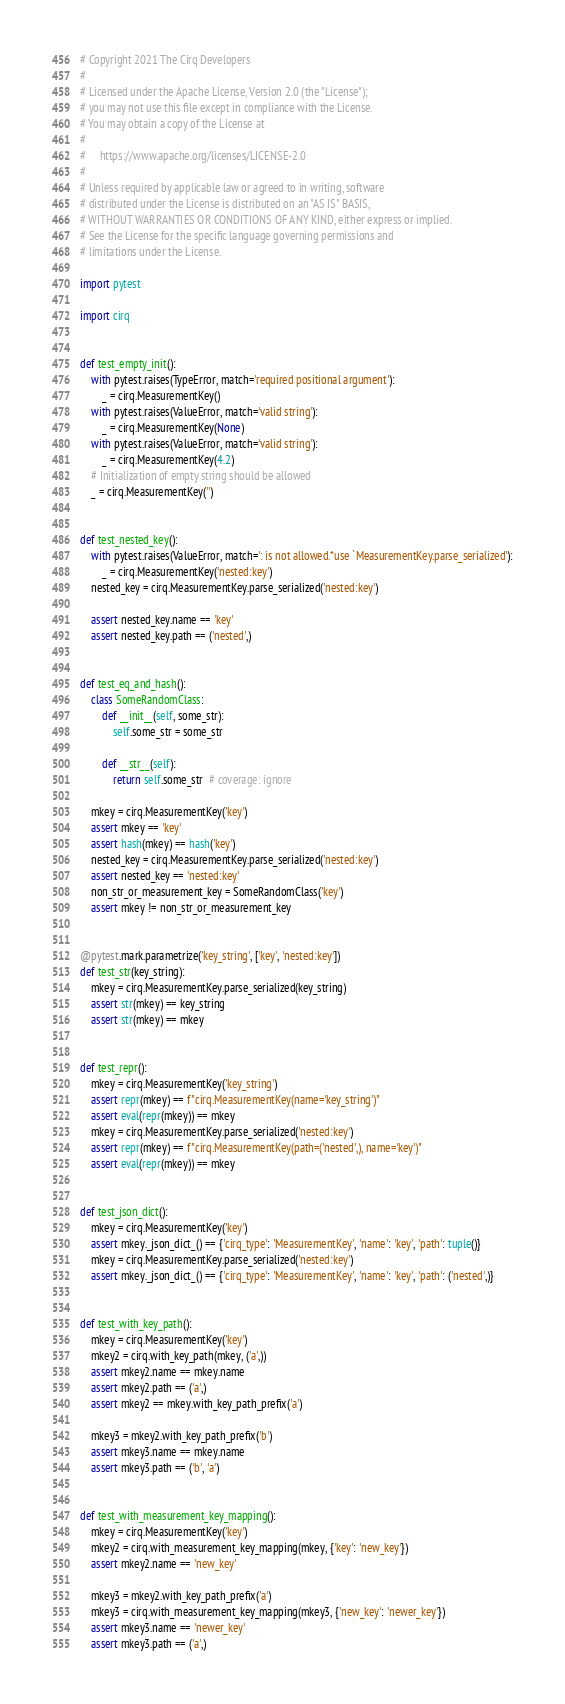<code> <loc_0><loc_0><loc_500><loc_500><_Python_># Copyright 2021 The Cirq Developers
#
# Licensed under the Apache License, Version 2.0 (the "License");
# you may not use this file except in compliance with the License.
# You may obtain a copy of the License at
#
#     https://www.apache.org/licenses/LICENSE-2.0
#
# Unless required by applicable law or agreed to in writing, software
# distributed under the License is distributed on an "AS IS" BASIS,
# WITHOUT WARRANTIES OR CONDITIONS OF ANY KIND, either express or implied.
# See the License for the specific language governing permissions and
# limitations under the License.

import pytest

import cirq


def test_empty_init():
    with pytest.raises(TypeError, match='required positional argument'):
        _ = cirq.MeasurementKey()
    with pytest.raises(ValueError, match='valid string'):
        _ = cirq.MeasurementKey(None)
    with pytest.raises(ValueError, match='valid string'):
        _ = cirq.MeasurementKey(4.2)
    # Initialization of empty string should be allowed
    _ = cirq.MeasurementKey('')


def test_nested_key():
    with pytest.raises(ValueError, match=': is not allowed.*use `MeasurementKey.parse_serialized'):
        _ = cirq.MeasurementKey('nested:key')
    nested_key = cirq.MeasurementKey.parse_serialized('nested:key')

    assert nested_key.name == 'key'
    assert nested_key.path == ('nested',)


def test_eq_and_hash():
    class SomeRandomClass:
        def __init__(self, some_str):
            self.some_str = some_str

        def __str__(self):
            return self.some_str  # coverage: ignore

    mkey = cirq.MeasurementKey('key')
    assert mkey == 'key'
    assert hash(mkey) == hash('key')
    nested_key = cirq.MeasurementKey.parse_serialized('nested:key')
    assert nested_key == 'nested:key'
    non_str_or_measurement_key = SomeRandomClass('key')
    assert mkey != non_str_or_measurement_key


@pytest.mark.parametrize('key_string', ['key', 'nested:key'])
def test_str(key_string):
    mkey = cirq.MeasurementKey.parse_serialized(key_string)
    assert str(mkey) == key_string
    assert str(mkey) == mkey


def test_repr():
    mkey = cirq.MeasurementKey('key_string')
    assert repr(mkey) == f"cirq.MeasurementKey(name='key_string')"
    assert eval(repr(mkey)) == mkey
    mkey = cirq.MeasurementKey.parse_serialized('nested:key')
    assert repr(mkey) == f"cirq.MeasurementKey(path=('nested',), name='key')"
    assert eval(repr(mkey)) == mkey


def test_json_dict():
    mkey = cirq.MeasurementKey('key')
    assert mkey._json_dict_() == {'cirq_type': 'MeasurementKey', 'name': 'key', 'path': tuple()}
    mkey = cirq.MeasurementKey.parse_serialized('nested:key')
    assert mkey._json_dict_() == {'cirq_type': 'MeasurementKey', 'name': 'key', 'path': ('nested',)}


def test_with_key_path():
    mkey = cirq.MeasurementKey('key')
    mkey2 = cirq.with_key_path(mkey, ('a',))
    assert mkey2.name == mkey.name
    assert mkey2.path == ('a',)
    assert mkey2 == mkey.with_key_path_prefix('a')

    mkey3 = mkey2.with_key_path_prefix('b')
    assert mkey3.name == mkey.name
    assert mkey3.path == ('b', 'a')


def test_with_measurement_key_mapping():
    mkey = cirq.MeasurementKey('key')
    mkey2 = cirq.with_measurement_key_mapping(mkey, {'key': 'new_key'})
    assert mkey2.name == 'new_key'

    mkey3 = mkey2.with_key_path_prefix('a')
    mkey3 = cirq.with_measurement_key_mapping(mkey3, {'new_key': 'newer_key'})
    assert mkey3.name == 'newer_key'
    assert mkey3.path == ('a',)
</code> 